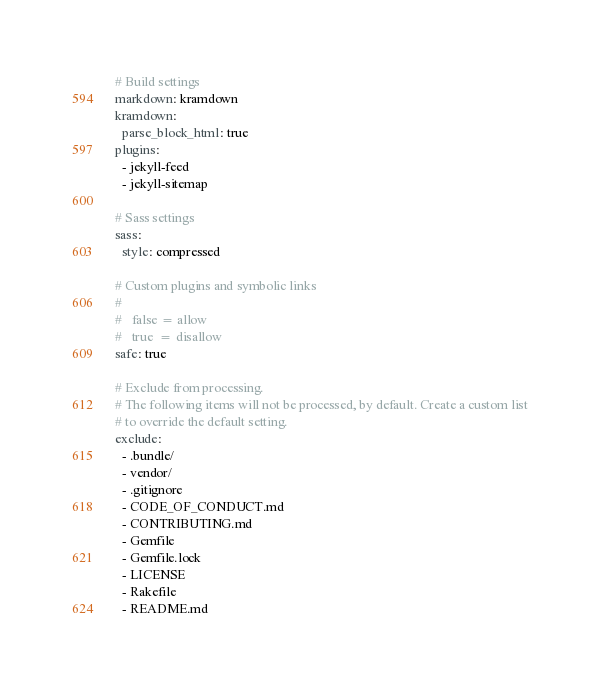<code> <loc_0><loc_0><loc_500><loc_500><_YAML_>
# Build settings
markdown: kramdown
kramdown:
  parse_block_html: true
plugins:
  - jekyll-feed
  - jekyll-sitemap

# Sass settings
sass:
  style: compressed

# Custom plugins and symbolic links
#
#   false = allow
#   true  = disallow
safe: true

# Exclude from processing.
# The following items will not be processed, by default. Create a custom list
# to override the default setting.
exclude:
  - .bundle/
  - vendor/
  - .gitignore
  - CODE_OF_CONDUCT.md
  - CONTRIBUTING.md
  - Gemfile
  - Gemfile.lock
  - LICENSE
  - Rakefile
  - README.md
</code> 